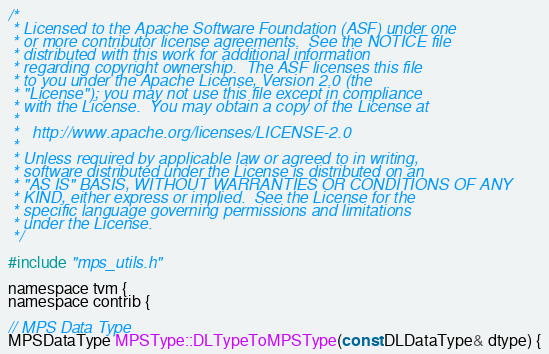<code> <loc_0><loc_0><loc_500><loc_500><_ObjectiveC_>/*
 * Licensed to the Apache Software Foundation (ASF) under one
 * or more contributor license agreements.  See the NOTICE file
 * distributed with this work for additional information
 * regarding copyright ownership.  The ASF licenses this file
 * to you under the Apache License, Version 2.0 (the
 * "License"); you may not use this file except in compliance
 * with the License.  You may obtain a copy of the License at
 *
 *   http://www.apache.org/licenses/LICENSE-2.0
 *
 * Unless required by applicable law or agreed to in writing,
 * software distributed under the License is distributed on an
 * "AS IS" BASIS, WITHOUT WARRANTIES OR CONDITIONS OF ANY
 * KIND, either express or implied.  See the License for the
 * specific language governing permissions and limitations
 * under the License.
 */

#include "mps_utils.h"

namespace tvm {
namespace contrib {

// MPS Data Type
MPSDataType MPSType::DLTypeToMPSType(const DLDataType& dtype) {</code> 